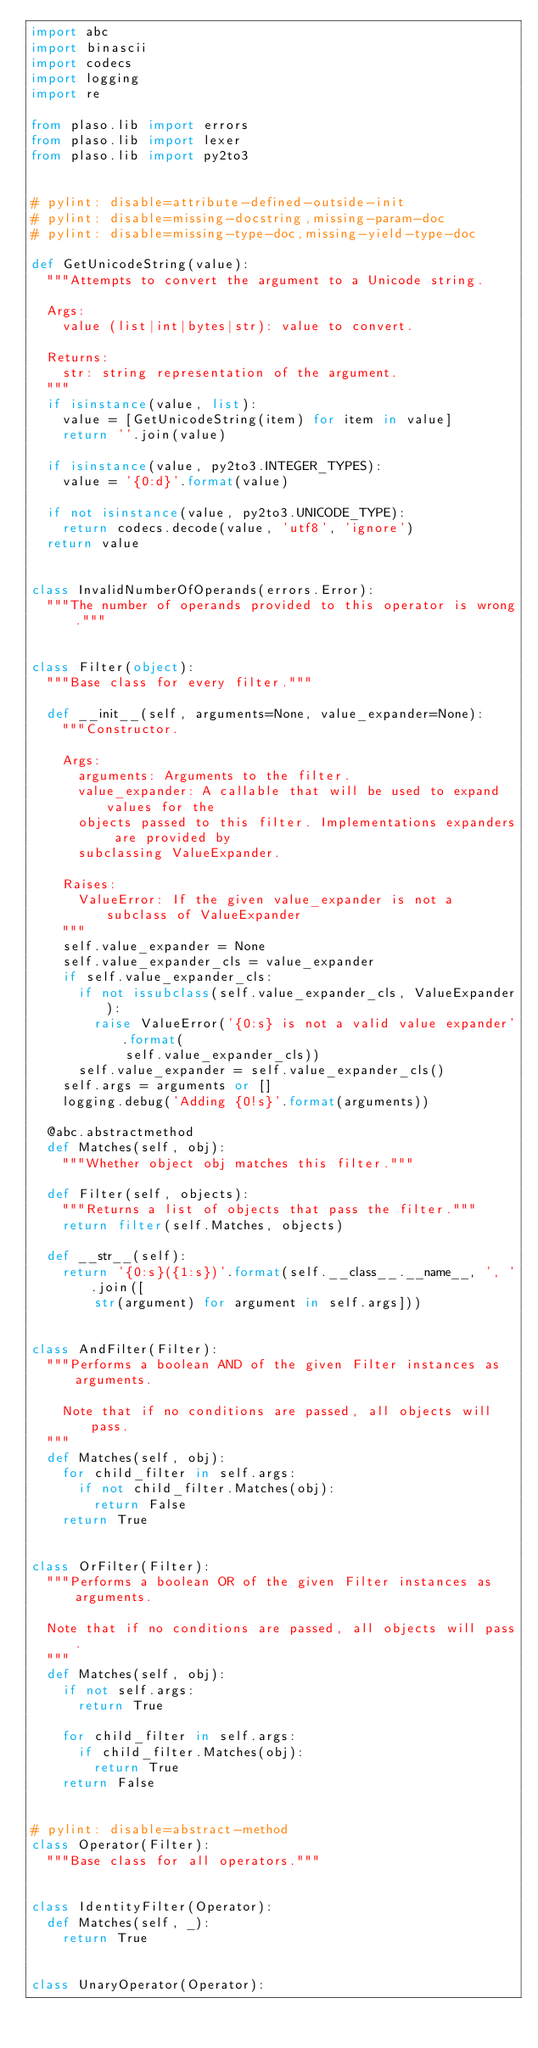Convert code to text. <code><loc_0><loc_0><loc_500><loc_500><_Python_>import abc
import binascii
import codecs
import logging
import re

from plaso.lib import errors
from plaso.lib import lexer
from plaso.lib import py2to3


# pylint: disable=attribute-defined-outside-init
# pylint: disable=missing-docstring,missing-param-doc
# pylint: disable=missing-type-doc,missing-yield-type-doc

def GetUnicodeString(value):
  """Attempts to convert the argument to a Unicode string.

  Args:
    value (list|int|bytes|str): value to convert.

  Returns:
    str: string representation of the argument.
  """
  if isinstance(value, list):
    value = [GetUnicodeString(item) for item in value]
    return ''.join(value)

  if isinstance(value, py2to3.INTEGER_TYPES):
    value = '{0:d}'.format(value)

  if not isinstance(value, py2to3.UNICODE_TYPE):
    return codecs.decode(value, 'utf8', 'ignore')
  return value


class InvalidNumberOfOperands(errors.Error):
  """The number of operands provided to this operator is wrong."""


class Filter(object):
  """Base class for every filter."""

  def __init__(self, arguments=None, value_expander=None):
    """Constructor.

    Args:
      arguments: Arguments to the filter.
      value_expander: A callable that will be used to expand values for the
      objects passed to this filter. Implementations expanders are provided by
      subclassing ValueExpander.

    Raises:
      ValueError: If the given value_expander is not a subclass of ValueExpander
    """
    self.value_expander = None
    self.value_expander_cls = value_expander
    if self.value_expander_cls:
      if not issubclass(self.value_expander_cls, ValueExpander):
        raise ValueError('{0:s} is not a valid value expander'.format(
            self.value_expander_cls))
      self.value_expander = self.value_expander_cls()
    self.args = arguments or []
    logging.debug('Adding {0!s}'.format(arguments))

  @abc.abstractmethod
  def Matches(self, obj):
    """Whether object obj matches this filter."""

  def Filter(self, objects):
    """Returns a list of objects that pass the filter."""
    return filter(self.Matches, objects)

  def __str__(self):
    return '{0:s}({1:s})'.format(self.__class__.__name__, ', '.join([
        str(argument) for argument in self.args]))


class AndFilter(Filter):
  """Performs a boolean AND of the given Filter instances as arguments.

    Note that if no conditions are passed, all objects will pass.
  """
  def Matches(self, obj):
    for child_filter in self.args:
      if not child_filter.Matches(obj):
        return False
    return True


class OrFilter(Filter):
  """Performs a boolean OR of the given Filter instances as arguments.

  Note that if no conditions are passed, all objects will pass.
  """
  def Matches(self, obj):
    if not self.args:
      return True

    for child_filter in self.args:
      if child_filter.Matches(obj):
        return True
    return False


# pylint: disable=abstract-method
class Operator(Filter):
  """Base class for all operators."""


class IdentityFilter(Operator):
  def Matches(self, _):
    return True


class UnaryOperator(Operator):</code> 